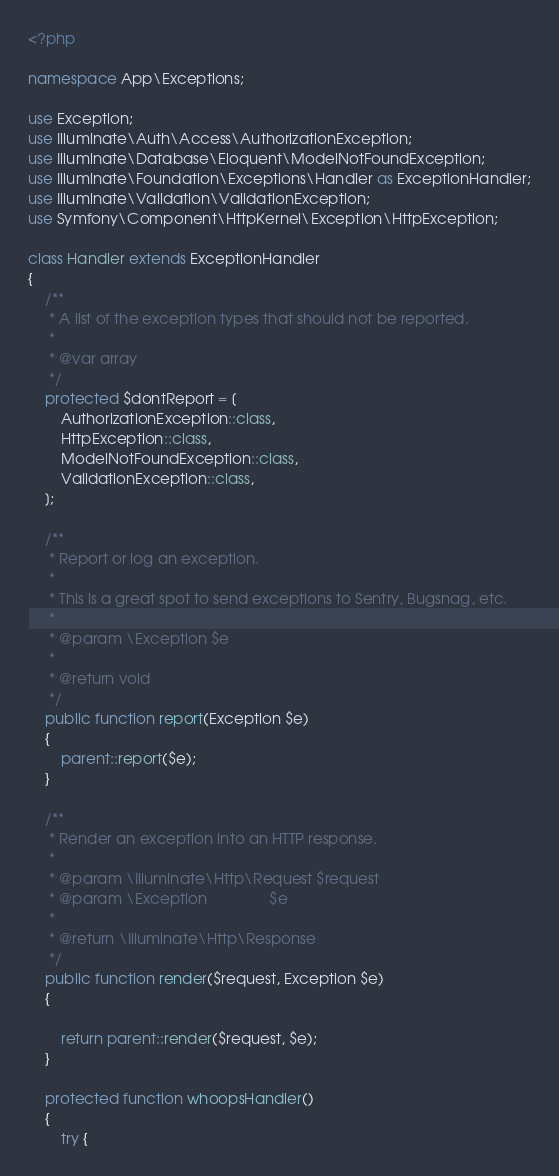<code> <loc_0><loc_0><loc_500><loc_500><_PHP_><?php

namespace App\Exceptions;

use Exception;
use Illuminate\Auth\Access\AuthorizationException;
use Illuminate\Database\Eloquent\ModelNotFoundException;
use Illuminate\Foundation\Exceptions\Handler as ExceptionHandler;
use Illuminate\Validation\ValidationException;
use Symfony\Component\HttpKernel\Exception\HttpException;

class Handler extends ExceptionHandler
{
    /**
     * A list of the exception types that should not be reported.
     *
     * @var array
     */
    protected $dontReport = [
        AuthorizationException::class,
        HttpException::class,
        ModelNotFoundException::class,
        ValidationException::class,
    ];

    /**
     * Report or log an exception.
     *
     * This is a great spot to send exceptions to Sentry, Bugsnag, etc.
     *
     * @param \Exception $e
     *
     * @return void
     */
    public function report(Exception $e)
    {
        parent::report($e);
    }

    /**
     * Render an exception into an HTTP response.
     *
     * @param \Illuminate\Http\Request $request
     * @param \Exception               $e
     *
     * @return \Illuminate\Http\Response
     */
    public function render($request, Exception $e)
    {

        return parent::render($request, $e);
    }

    protected function whoopsHandler()
    {
        try {</code> 